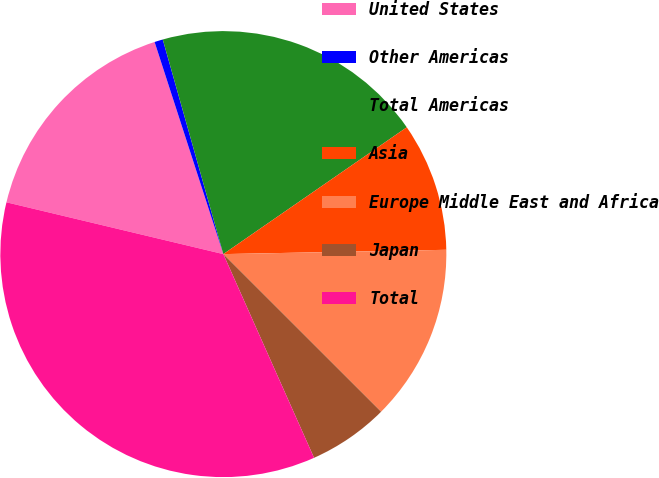Convert chart. <chart><loc_0><loc_0><loc_500><loc_500><pie_chart><fcel>United States<fcel>Other Americas<fcel>Total Americas<fcel>Asia<fcel>Europe Middle East and Africa<fcel>Japan<fcel>Total<nl><fcel>16.28%<fcel>0.61%<fcel>19.75%<fcel>9.32%<fcel>12.8%<fcel>5.84%<fcel>35.4%<nl></chart> 